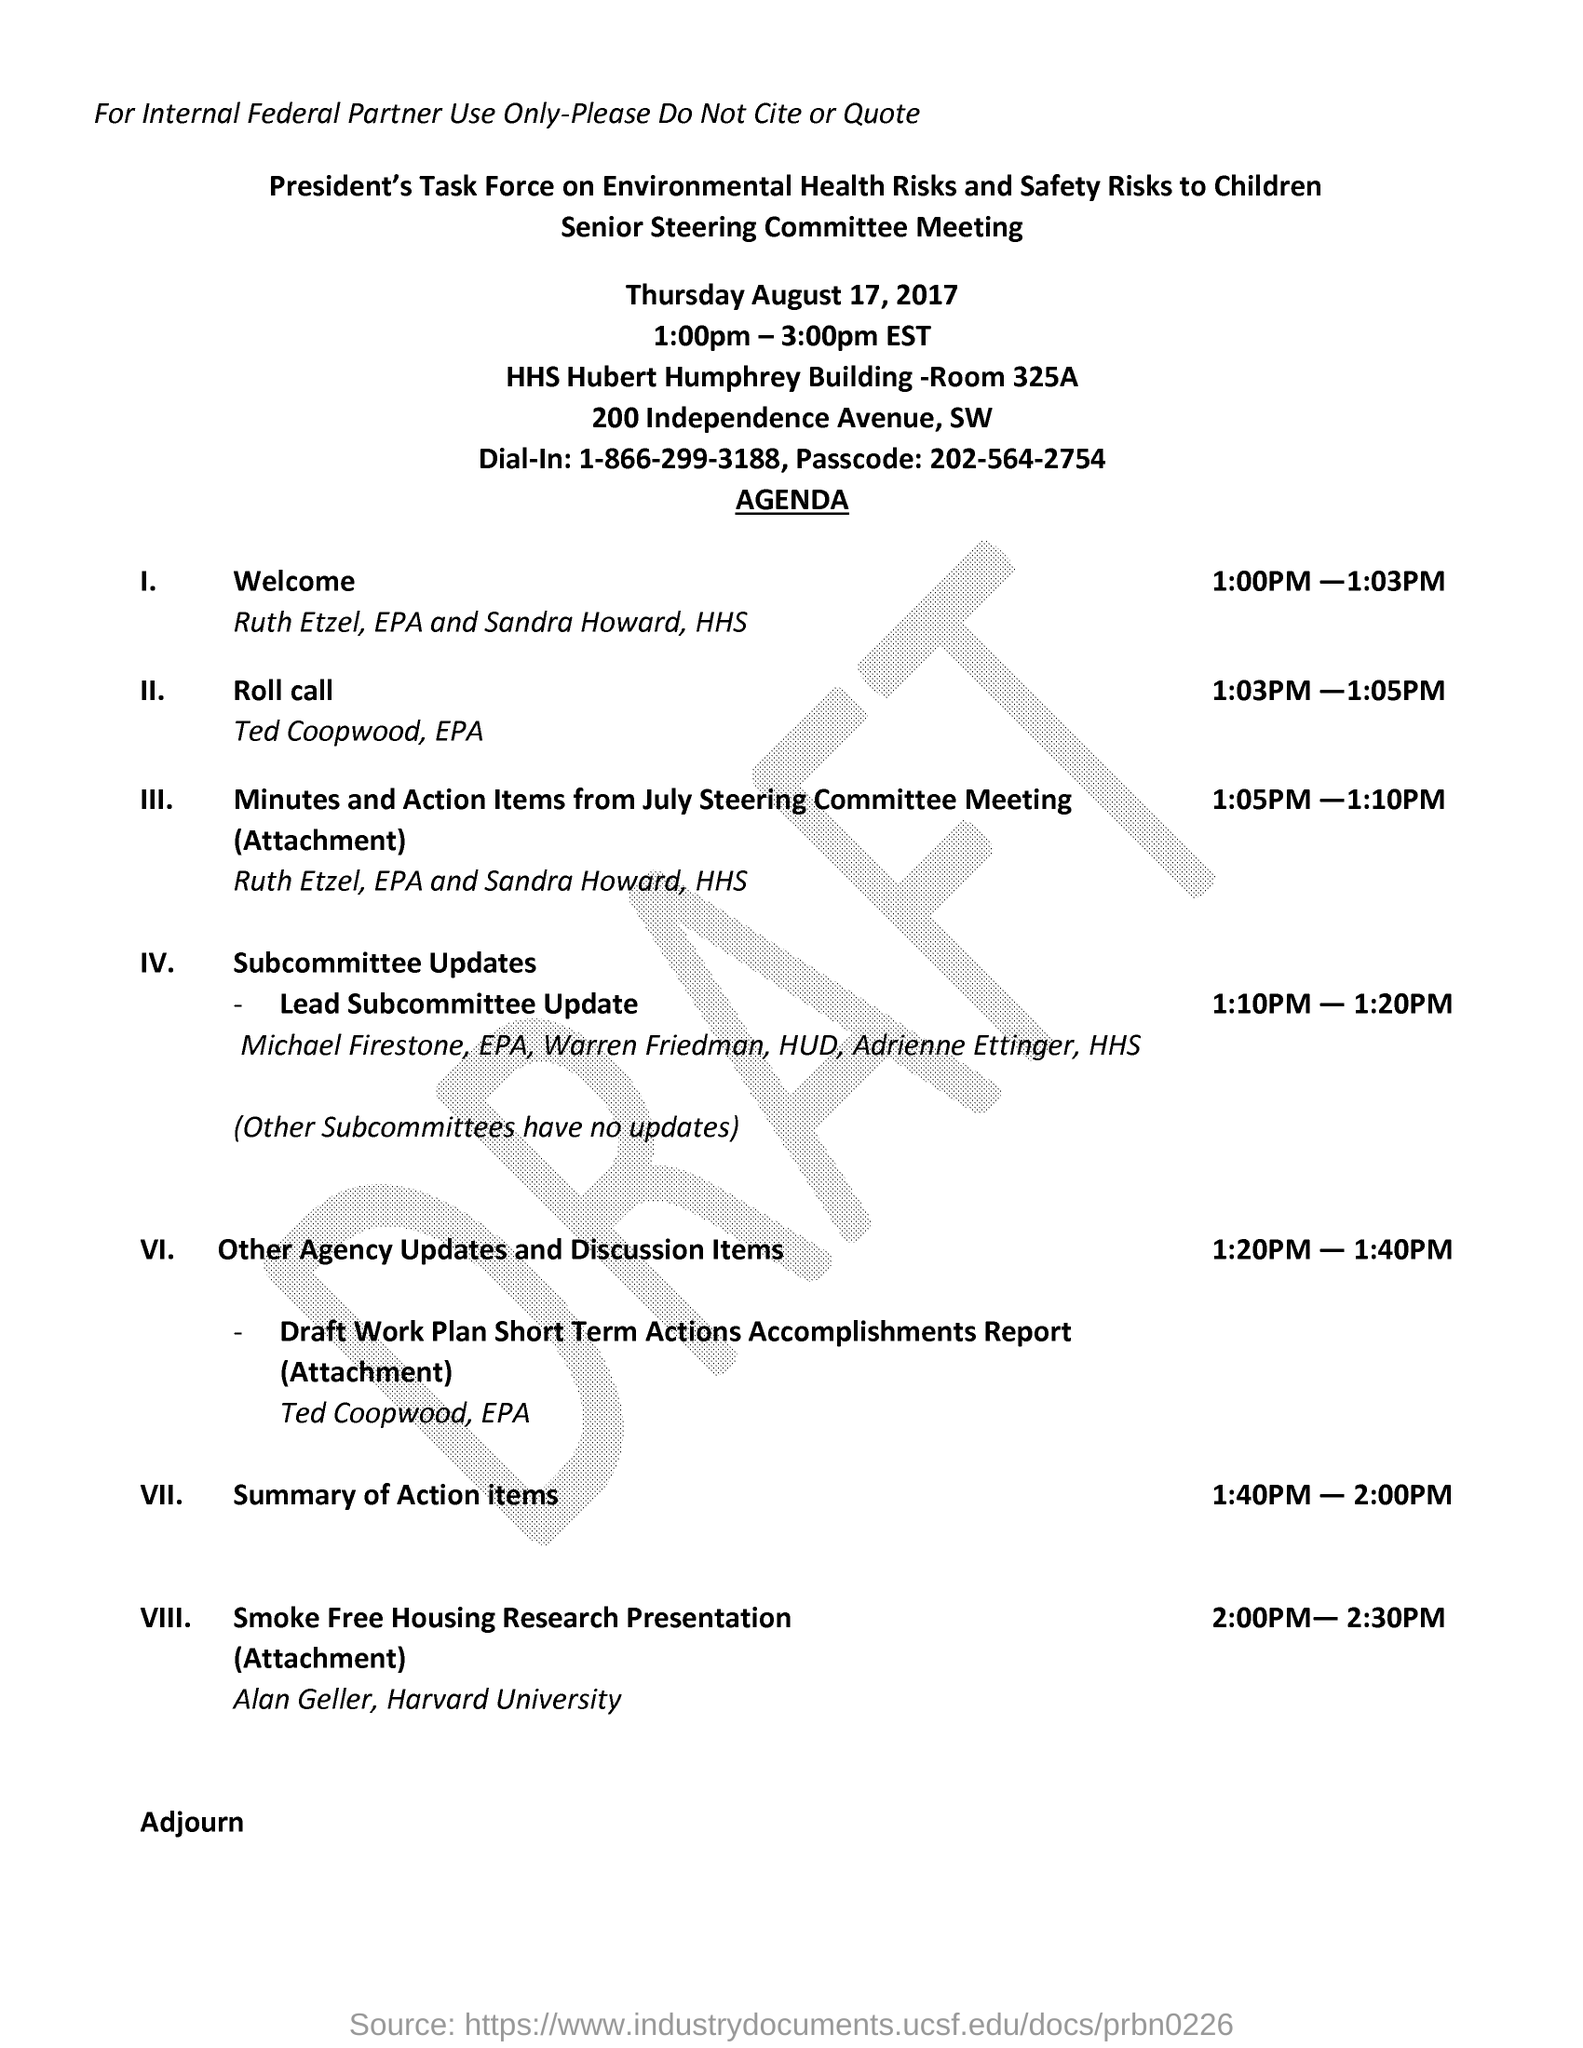Point out several critical features in this image. The welcome is scheduled to occur between the timings of 1:00 PM and 1:03 PM. The given daily-in number is 1-866-299-3188. The senior steering committee meeting is scheduled to take place from 1:00 pm to 3:00 pm (Eastern Standard Time). The senior steering committee meeting was conducted on Thursday, August 17, 2017. The senior steering committee is holding its meeting in the Hubert Humphery building, in Room 325A. 